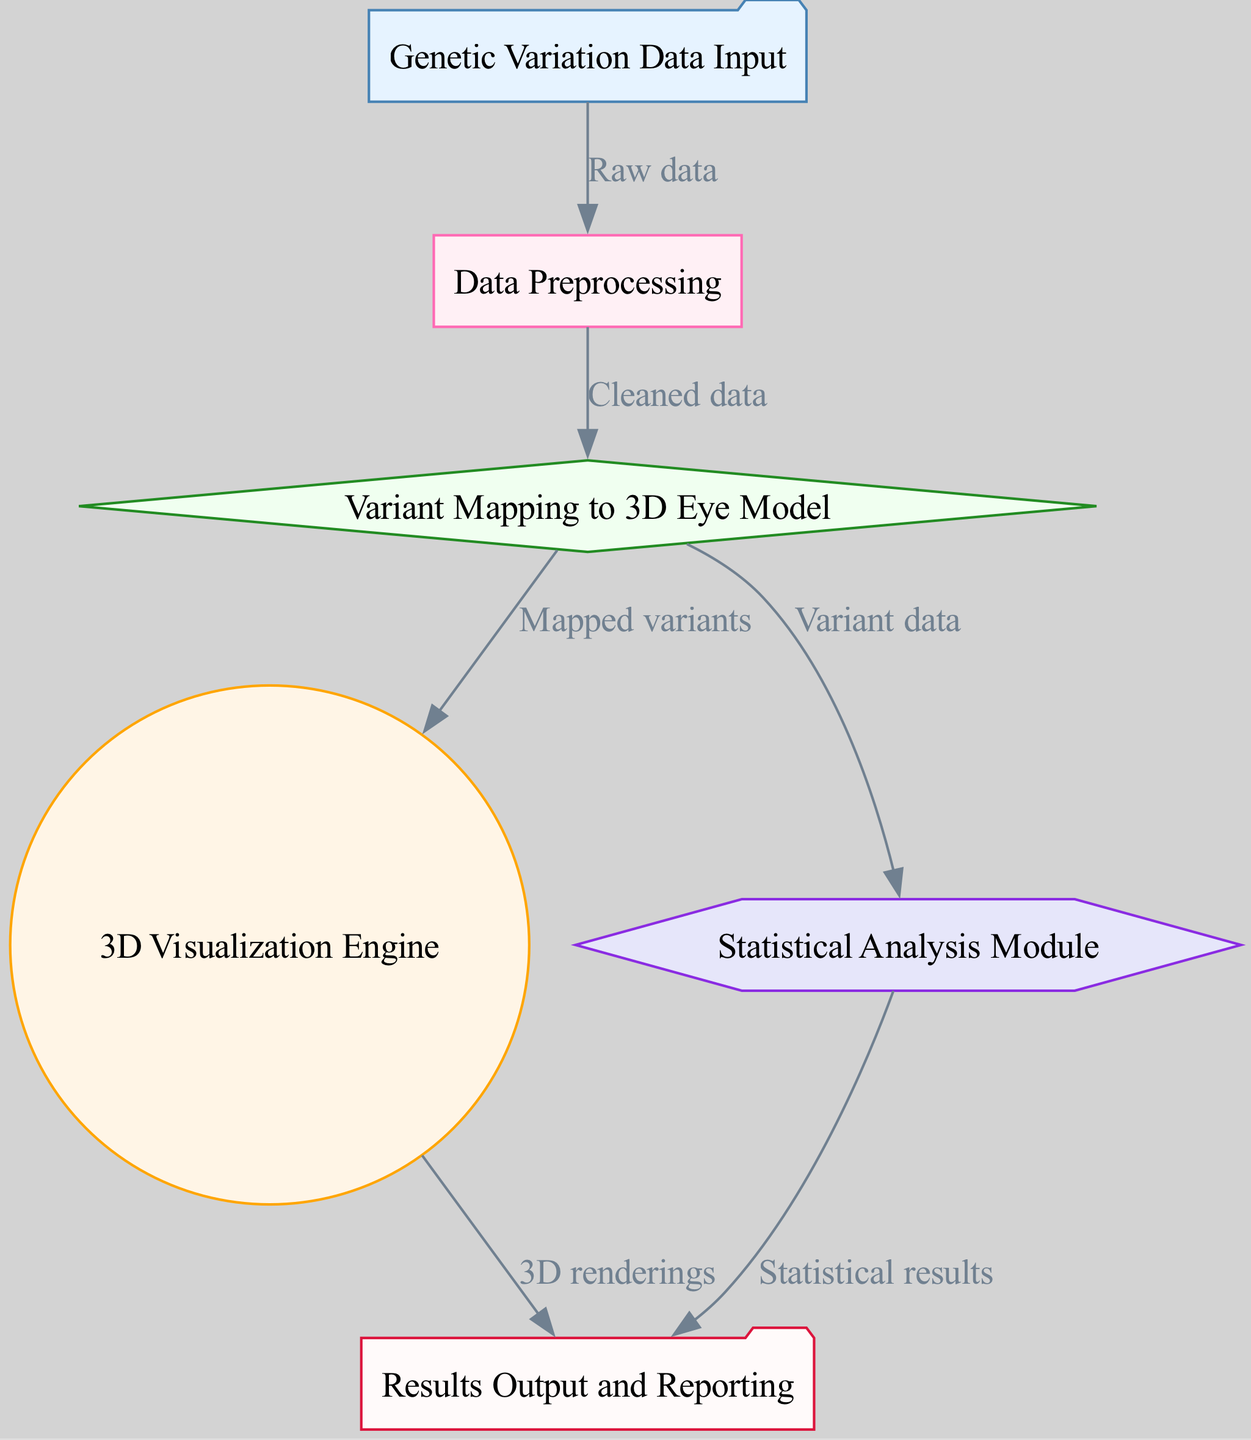What is the first step in the process? The diagram indicates that the first step involves the "Genetic Variation Data Input" node, which serves as the starting point for data traffic.
Answer: Genetic Variation Data Input How many nodes are in the diagram? By counting the distinct node labels provided in the diagram, there are six nodes, each representing a unique functional component.
Answer: 6 What does the "Data Preprocessing" node receive as input? The input for the "Data Preprocessing" node comes from the "Genetic Variation Data Input" node, with the label showing the flow of "Raw data."
Answer: Raw data Which node sends "Mapped variants" to the "3D Visualization Engine"? The "Variant Mapping to 3D Eye Model" node is responsible for sending "Mapped variants" to the "3D Visualization Engine," as indicated by the directed edge.
Answer: Variant Mapping to 3D Eye Model What are the outputs of the "Statistical Analysis Module"? The "Statistical Analysis Module" outputs "Statistical results," which is directed towards the output node for reporting purposes.
Answer: Statistical results Which two nodes receive input from the "Variant Mapping to 3D Eye Model" node? The "Variant Mapping to 3D Eye Model" node sends output to both the "3D Visualization Engine" and the "Statistical Analysis Module," as shown by the respective edges leading from it.
Answer: 3D Visualization Engine, Statistical Analysis Module What is the purpose of the "3D Visualization Engine"? The purpose of the "3D Visualization Engine" is to produce "3D renderings," as indicated by its outgoing edge towards the output node.
Answer: 3D renderings What type of diagram is this? The diagram represents an engineering diagram that outlines the flow and structure of a custom-built software tool used for visualization and analysis purposes.
Answer: Engineering Diagram 